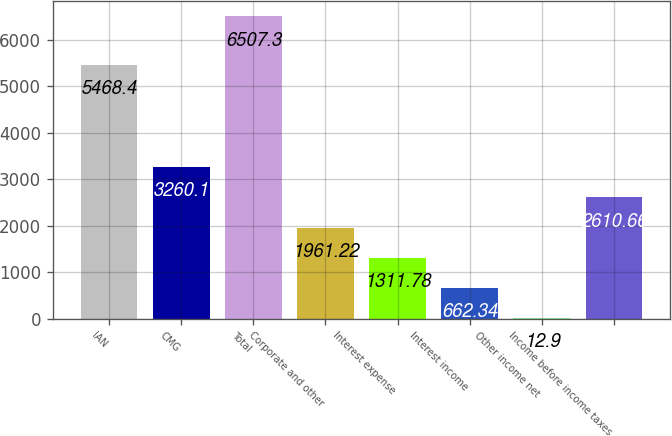Convert chart to OTSL. <chart><loc_0><loc_0><loc_500><loc_500><bar_chart><fcel>IAN<fcel>CMG<fcel>Total<fcel>Corporate and other<fcel>Interest expense<fcel>Interest income<fcel>Other income net<fcel>Income before income taxes<nl><fcel>5468.4<fcel>3260.1<fcel>6507.3<fcel>1961.22<fcel>1311.78<fcel>662.34<fcel>12.9<fcel>2610.66<nl></chart> 